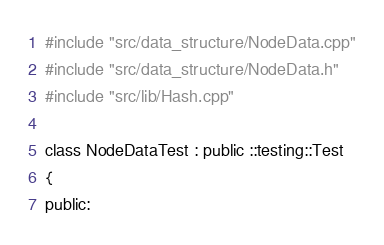Convert code to text. <code><loc_0><loc_0><loc_500><loc_500><_C_>
#include "src/data_structure/NodeData.cpp"
#include "src/data_structure/NodeData.h"
#include "src/lib/Hash.cpp"

class NodeDataTest : public ::testing::Test
{
public:</code> 